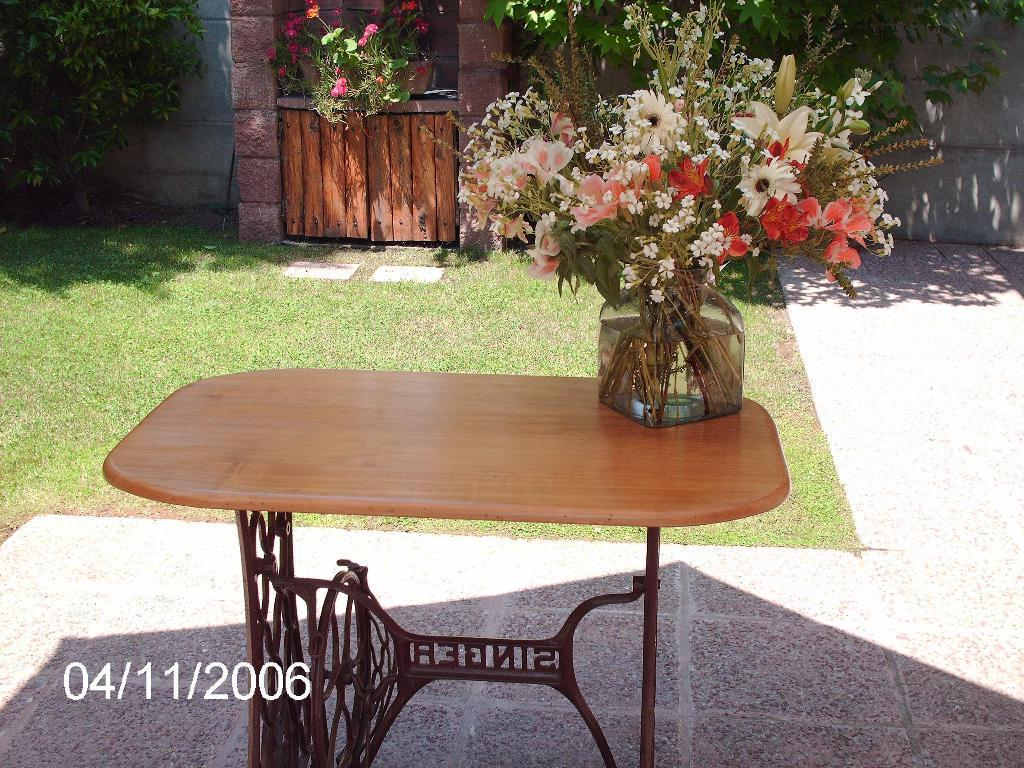What is placed on the table in the image? There is a flower vase on a table. What can be seen near the table? There is a grass patch beside the table. What is on the door in the background? A door is decorated with a bouquet in the background. What is located near the door? There are plants beside the door. What color is the nail polish on the mom's hand in the image? There is no mom or nail polish present in the image. 